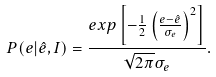<formula> <loc_0><loc_0><loc_500><loc_500>P ( e | \hat { e } , I ) = \frac { e x p \left [ - \frac { 1 } { 2 } \left ( \frac { e - \hat { e } } { \sigma _ { e } } \right ) ^ { 2 } \right ] } { \sqrt { 2 \pi } \sigma _ { e } } .</formula> 